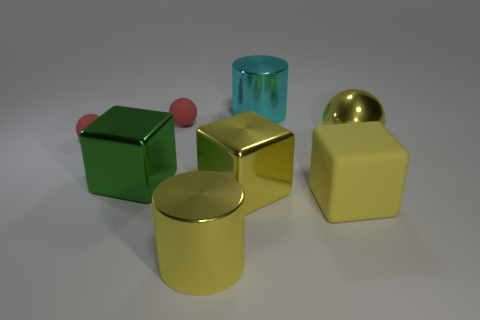Add 2 small matte cylinders. How many objects exist? 10 Subtract all cylinders. How many objects are left? 6 Subtract all red matte balls. Subtract all large balls. How many objects are left? 5 Add 3 big yellow spheres. How many big yellow spheres are left? 4 Add 6 green objects. How many green objects exist? 7 Subtract 0 blue balls. How many objects are left? 8 